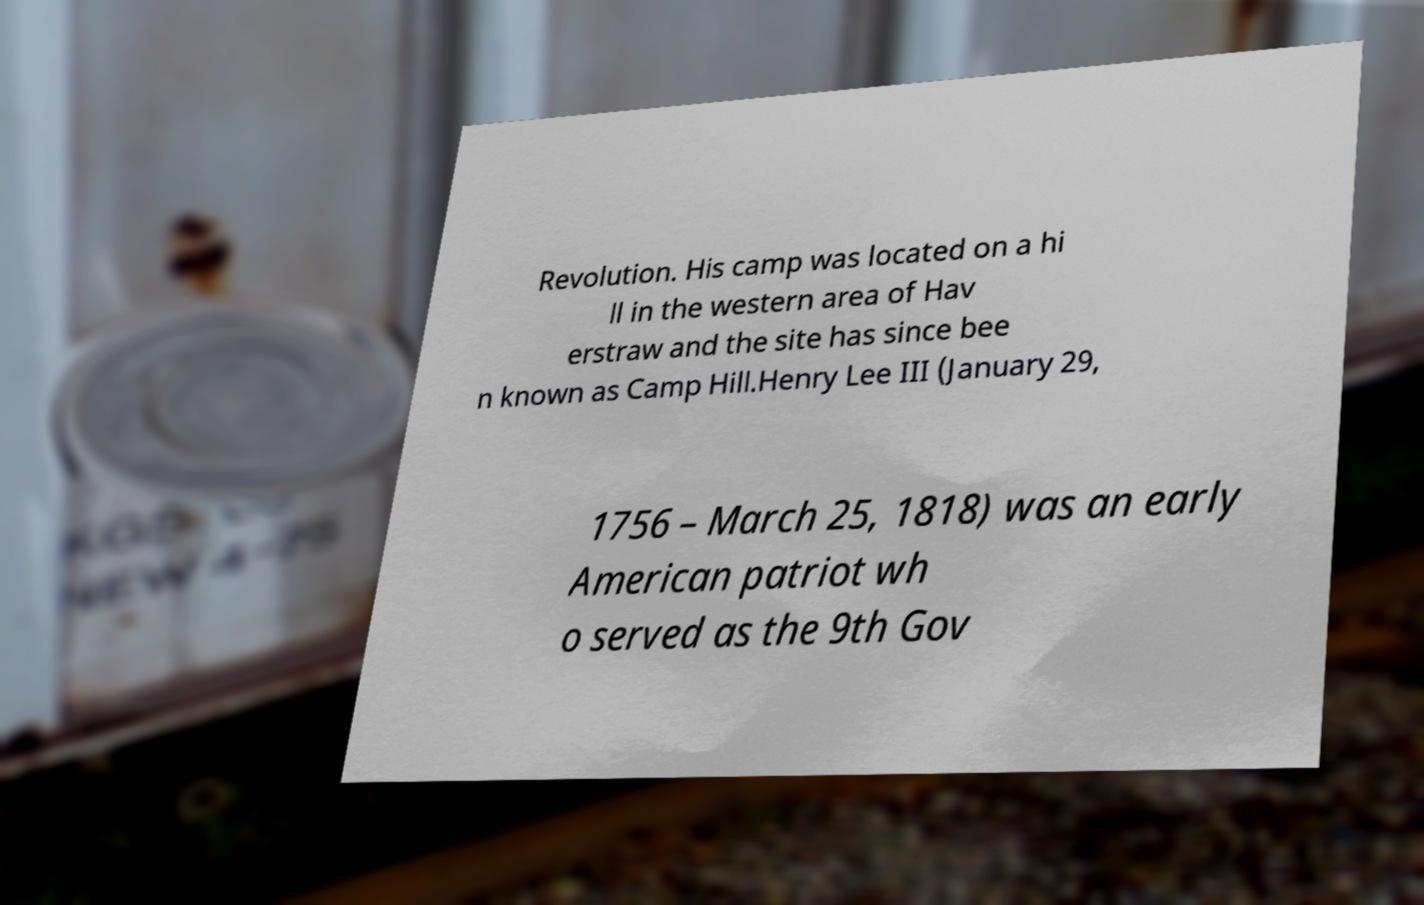Can you read and provide the text displayed in the image?This photo seems to have some interesting text. Can you extract and type it out for me? Revolution. His camp was located on a hi ll in the western area of Hav erstraw and the site has since bee n known as Camp Hill.Henry Lee III (January 29, 1756 – March 25, 1818) was an early American patriot wh o served as the 9th Gov 